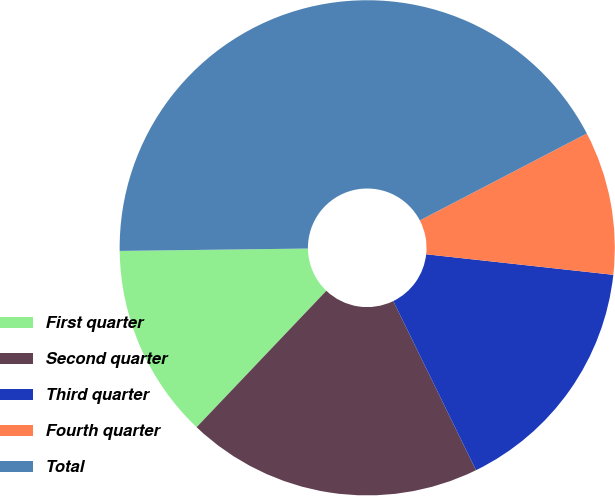<chart> <loc_0><loc_0><loc_500><loc_500><pie_chart><fcel>First quarter<fcel>Second quarter<fcel>Third quarter<fcel>Fourth quarter<fcel>Total<nl><fcel>12.7%<fcel>19.34%<fcel>16.02%<fcel>9.38%<fcel>42.56%<nl></chart> 